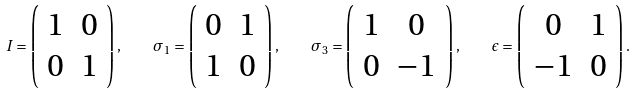<formula> <loc_0><loc_0><loc_500><loc_500>I = \left ( \begin{array} { c c } 1 & 0 \\ 0 & 1 \end{array} \right ) , \quad \sigma _ { 1 } = \left ( \begin{array} { c c } 0 & 1 \\ 1 & 0 \end{array} \right ) , \quad \sigma _ { 3 } = \left ( \begin{array} { c c } 1 & 0 \\ 0 & - 1 \end{array} \right ) , \quad \epsilon = \left ( \begin{array} { c c } 0 & 1 \\ - 1 & 0 \end{array} \right ) .</formula> 